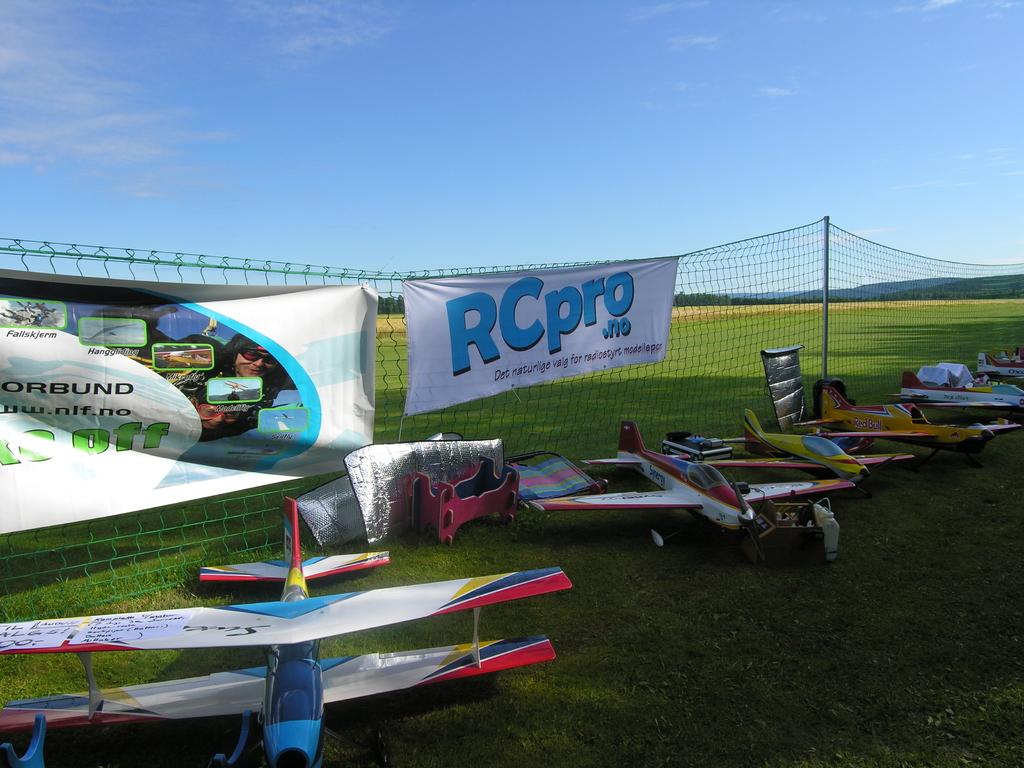Who is one of the advertisers?
Keep it short and to the point. Rcpro. What is written in green?
Provide a succinct answer. Off. 